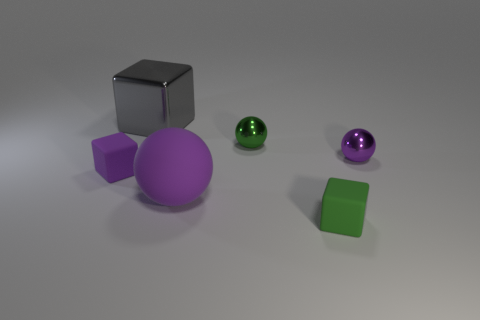What is the color of the metal ball that is the same size as the purple metallic thing? green 